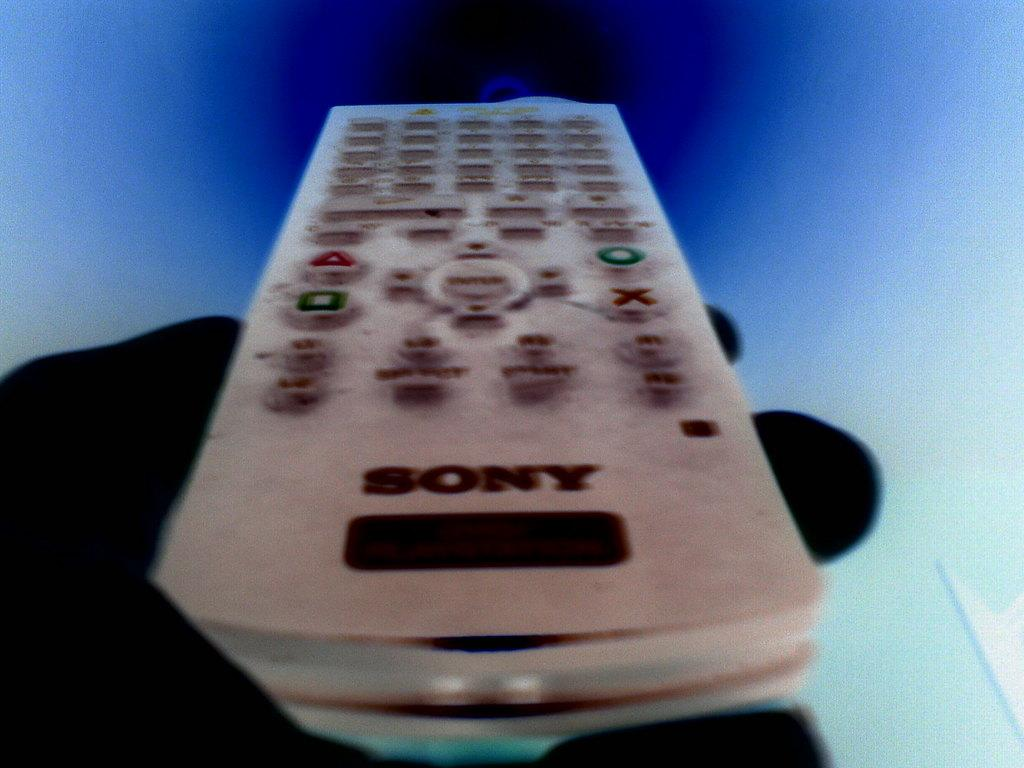Provide a one-sentence caption for the provided image. Television remote mady by Sony with play button, enter button and stop button. 